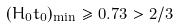Convert formula to latex. <formula><loc_0><loc_0><loc_500><loc_500>( H _ { 0 } t _ { 0 } ) _ { \min } \geq 0 . 7 3 > 2 / 3</formula> 